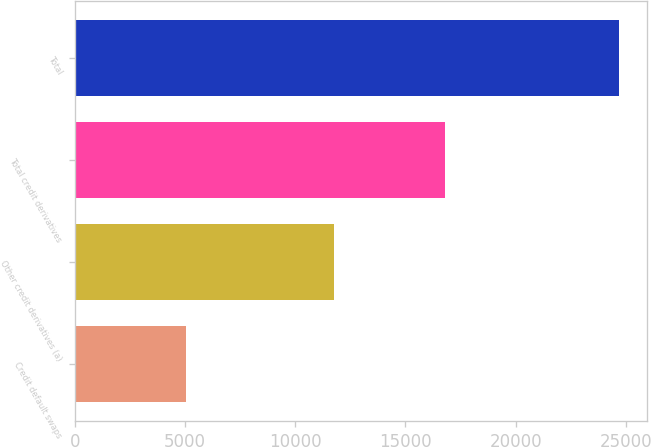Convert chart. <chart><loc_0><loc_0><loc_500><loc_500><bar_chart><fcel>Credit default swaps<fcel>Other credit derivatives (a)<fcel>Total credit derivatives<fcel>Total<nl><fcel>5045<fcel>11747<fcel>16792<fcel>24707<nl></chart> 